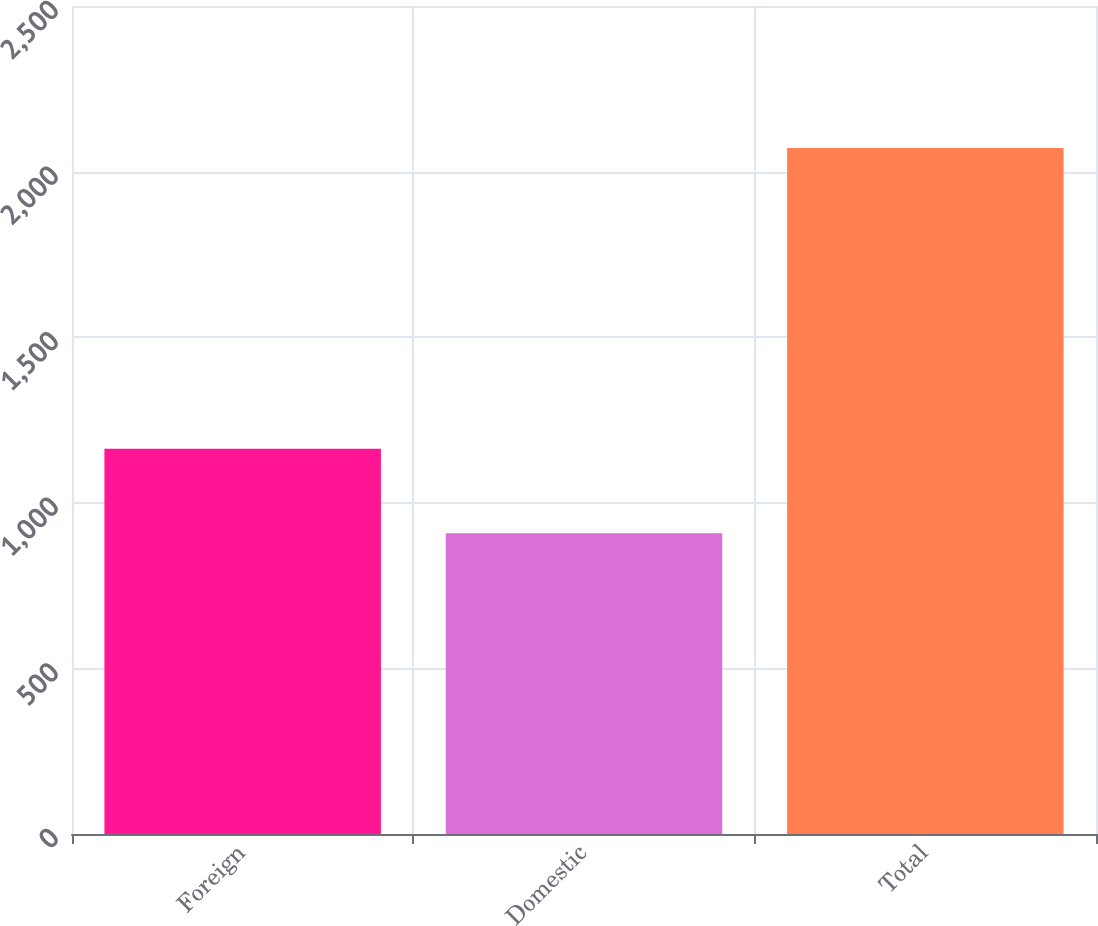Convert chart to OTSL. <chart><loc_0><loc_0><loc_500><loc_500><bar_chart><fcel>Foreign<fcel>Domestic<fcel>Total<nl><fcel>1163<fcel>908<fcel>2071<nl></chart> 